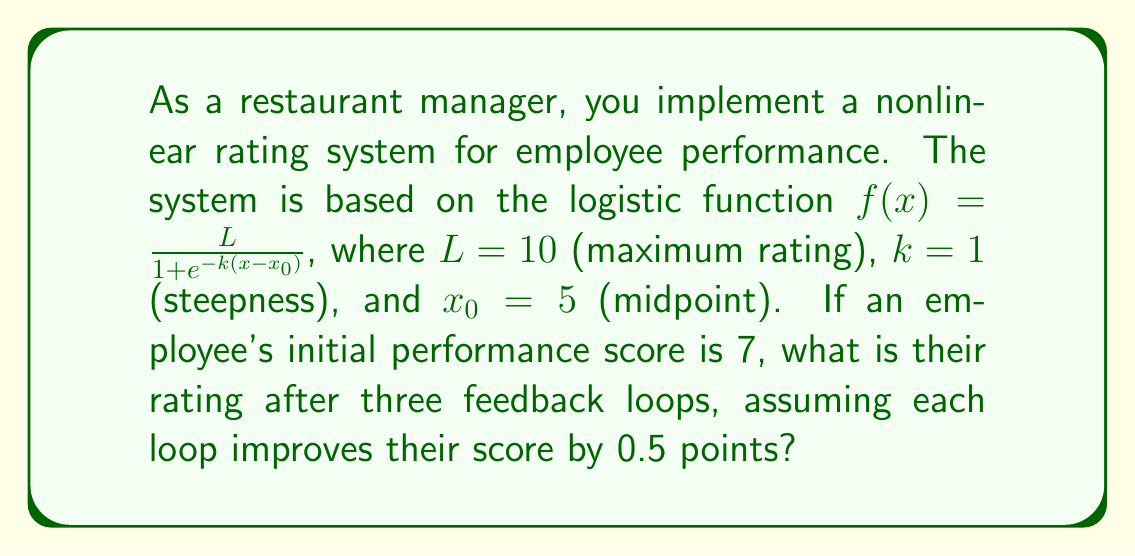What is the answer to this math problem? 1. The logistic function for this rating system is:
   $$f(x) = \frac{10}{1 + e^{-(x-5)}}$$

2. The employee's initial score is 7. After three feedback loops, each improving by 0.5 points:
   New score = $7 + (3 \times 0.5) = 8.5$

3. Now, we substitute $x=8.5$ into our logistic function:
   $$f(8.5) = \frac{10}{1 + e^{-(8.5-5)}} = \frac{10}{1 + e^{-3.5}}$$

4. Simplify the exponential:
   $$e^{-3.5} \approx 0.0302$$

5. Calculate the denominator:
   $$1 + 0.0302 = 1.0302$$

6. Divide:
   $$\frac{10}{1.0302} \approx 9.7068$$

7. Round to two decimal places:
   $$9.71$$
Answer: 9.71 